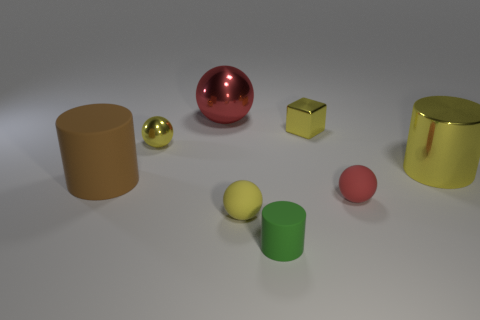Add 2 tiny red matte objects. How many objects exist? 10 Subtract all cylinders. How many objects are left? 5 Subtract 0 gray cylinders. How many objects are left? 8 Subtract all rubber cylinders. Subtract all tiny purple blocks. How many objects are left? 6 Add 3 green objects. How many green objects are left? 4 Add 8 tiny yellow metallic balls. How many tiny yellow metallic balls exist? 9 